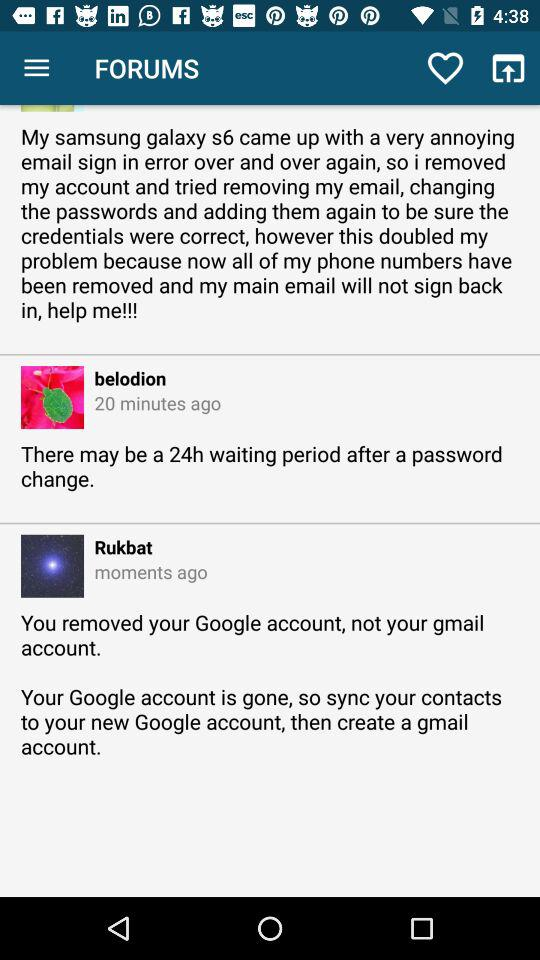When did Rukbat say something? Rukbat said something a moment ago. 